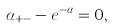Convert formula to latex. <formula><loc_0><loc_0><loc_500><loc_500>\alpha _ { + - } - e ^ { - \alpha } = 0 ,</formula> 